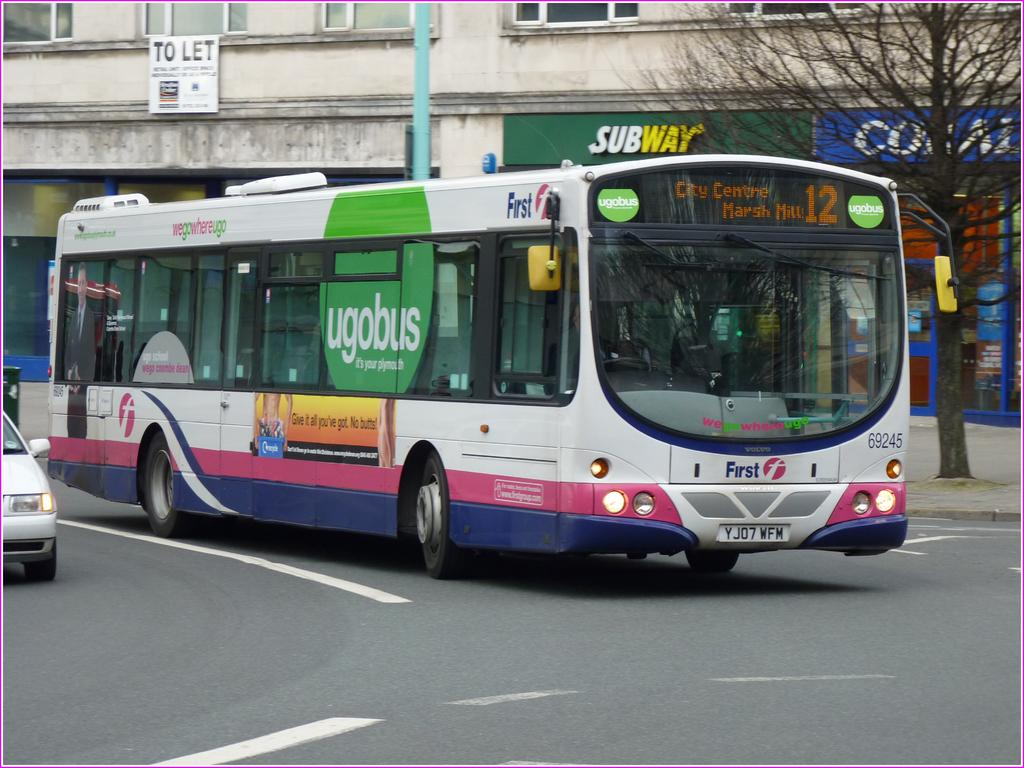<image>
Write a terse but informative summary of the picture. A bus starts to turn a corner in front of Subway location. 